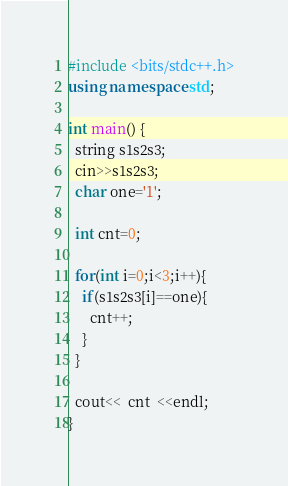<code> <loc_0><loc_0><loc_500><loc_500><_C++_>#include <bits/stdc++.h>
using namespace std;
 
int main() {
  string s1s2s3;
  cin>>s1s2s3;
  char one='1';
  
  int cnt=0;
  
  for(int i=0;i<3;i++){
    if(s1s2s3[i]==one){
      cnt++;
    }
  }
  
  cout<<  cnt  <<endl;
}</code> 